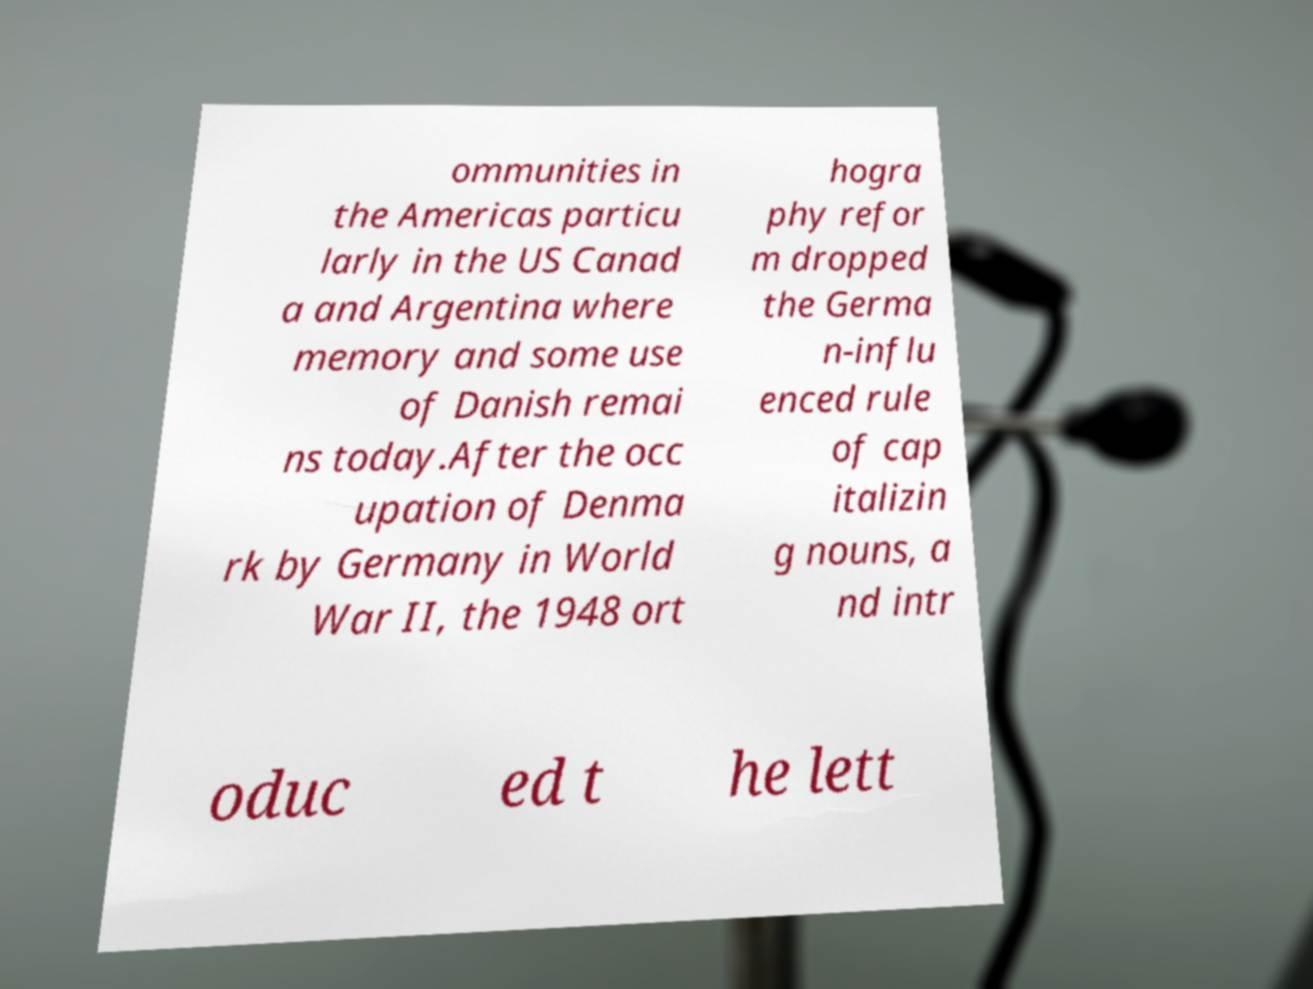Can you accurately transcribe the text from the provided image for me? ommunities in the Americas particu larly in the US Canad a and Argentina where memory and some use of Danish remai ns today.After the occ upation of Denma rk by Germany in World War II, the 1948 ort hogra phy refor m dropped the Germa n-influ enced rule of cap italizin g nouns, a nd intr oduc ed t he lett 